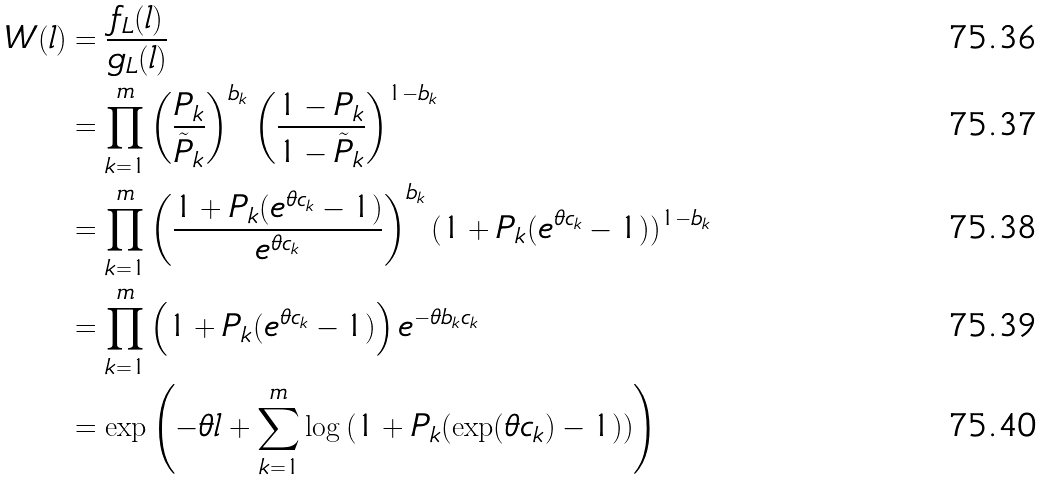Convert formula to latex. <formula><loc_0><loc_0><loc_500><loc_500>W ( l ) & = \frac { f _ { L } ( l ) } { g _ { L } ( l ) } \\ & = \prod _ { k = 1 } ^ { m } \left ( \frac { P _ { k } } { \tilde { P } _ { k } } \right ) ^ { b _ { k } } \left ( \frac { 1 - P _ { k } } { 1 - \tilde { P } _ { k } } \right ) ^ { 1 - b _ { k } } \\ & = \prod _ { k = 1 } ^ { m } \left ( \frac { 1 + P _ { k } ( e ^ { \theta c _ { k } } - 1 ) } { e ^ { \theta c _ { k } } } \right ) ^ { b _ { k } } ( 1 + P _ { k } ( e ^ { \theta c _ { k } } - 1 ) ) ^ { 1 - b _ { k } } \\ & = \prod _ { k = 1 } ^ { m } \left ( 1 + P _ { k } ( e ^ { \theta c _ { k } } - 1 ) \right ) e ^ { - \theta b _ { k } c _ { k } } \\ & = \exp \left ( - \theta l + \sum _ { k = 1 } ^ { m } \log \left ( 1 + P _ { k } ( \exp ( \theta c _ { k } ) - 1 ) \right ) \right )</formula> 